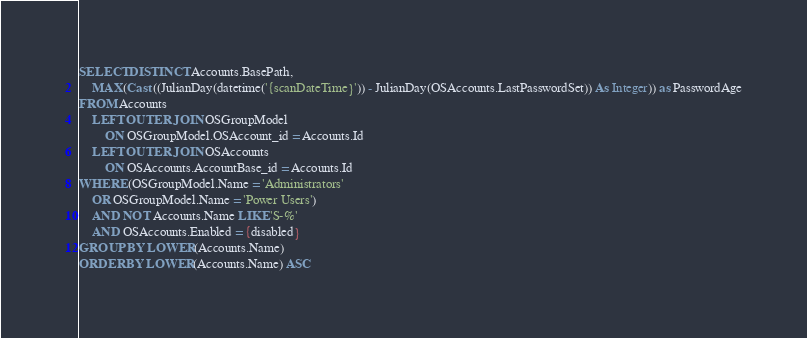<code> <loc_0><loc_0><loc_500><loc_500><_SQL_>SELECT DISTINCT Accounts.BasePath,
	MAX(Cast ((JulianDay(datetime('{scanDateTime}')) - JulianDay(OSAccounts.LastPasswordSet)) As Integer)) as PasswordAge
FROM Accounts
	LEFT OUTER JOIN OSGroupModel
		ON OSGroupModel.OSAccount_id = Accounts.Id
	LEFT OUTER JOIN OSAccounts
		ON OSAccounts.AccountBase_id = Accounts.Id
WHERE (OSGroupModel.Name = 'Administrators'
	OR OSGroupModel.Name = 'Power Users')
	AND NOT Accounts.Name LIKE 'S-%'
	AND OSAccounts.Enabled = {disabled}
GROUP BY LOWER(Accounts.Name)
ORDER BY LOWER(Accounts.Name) ASC</code> 